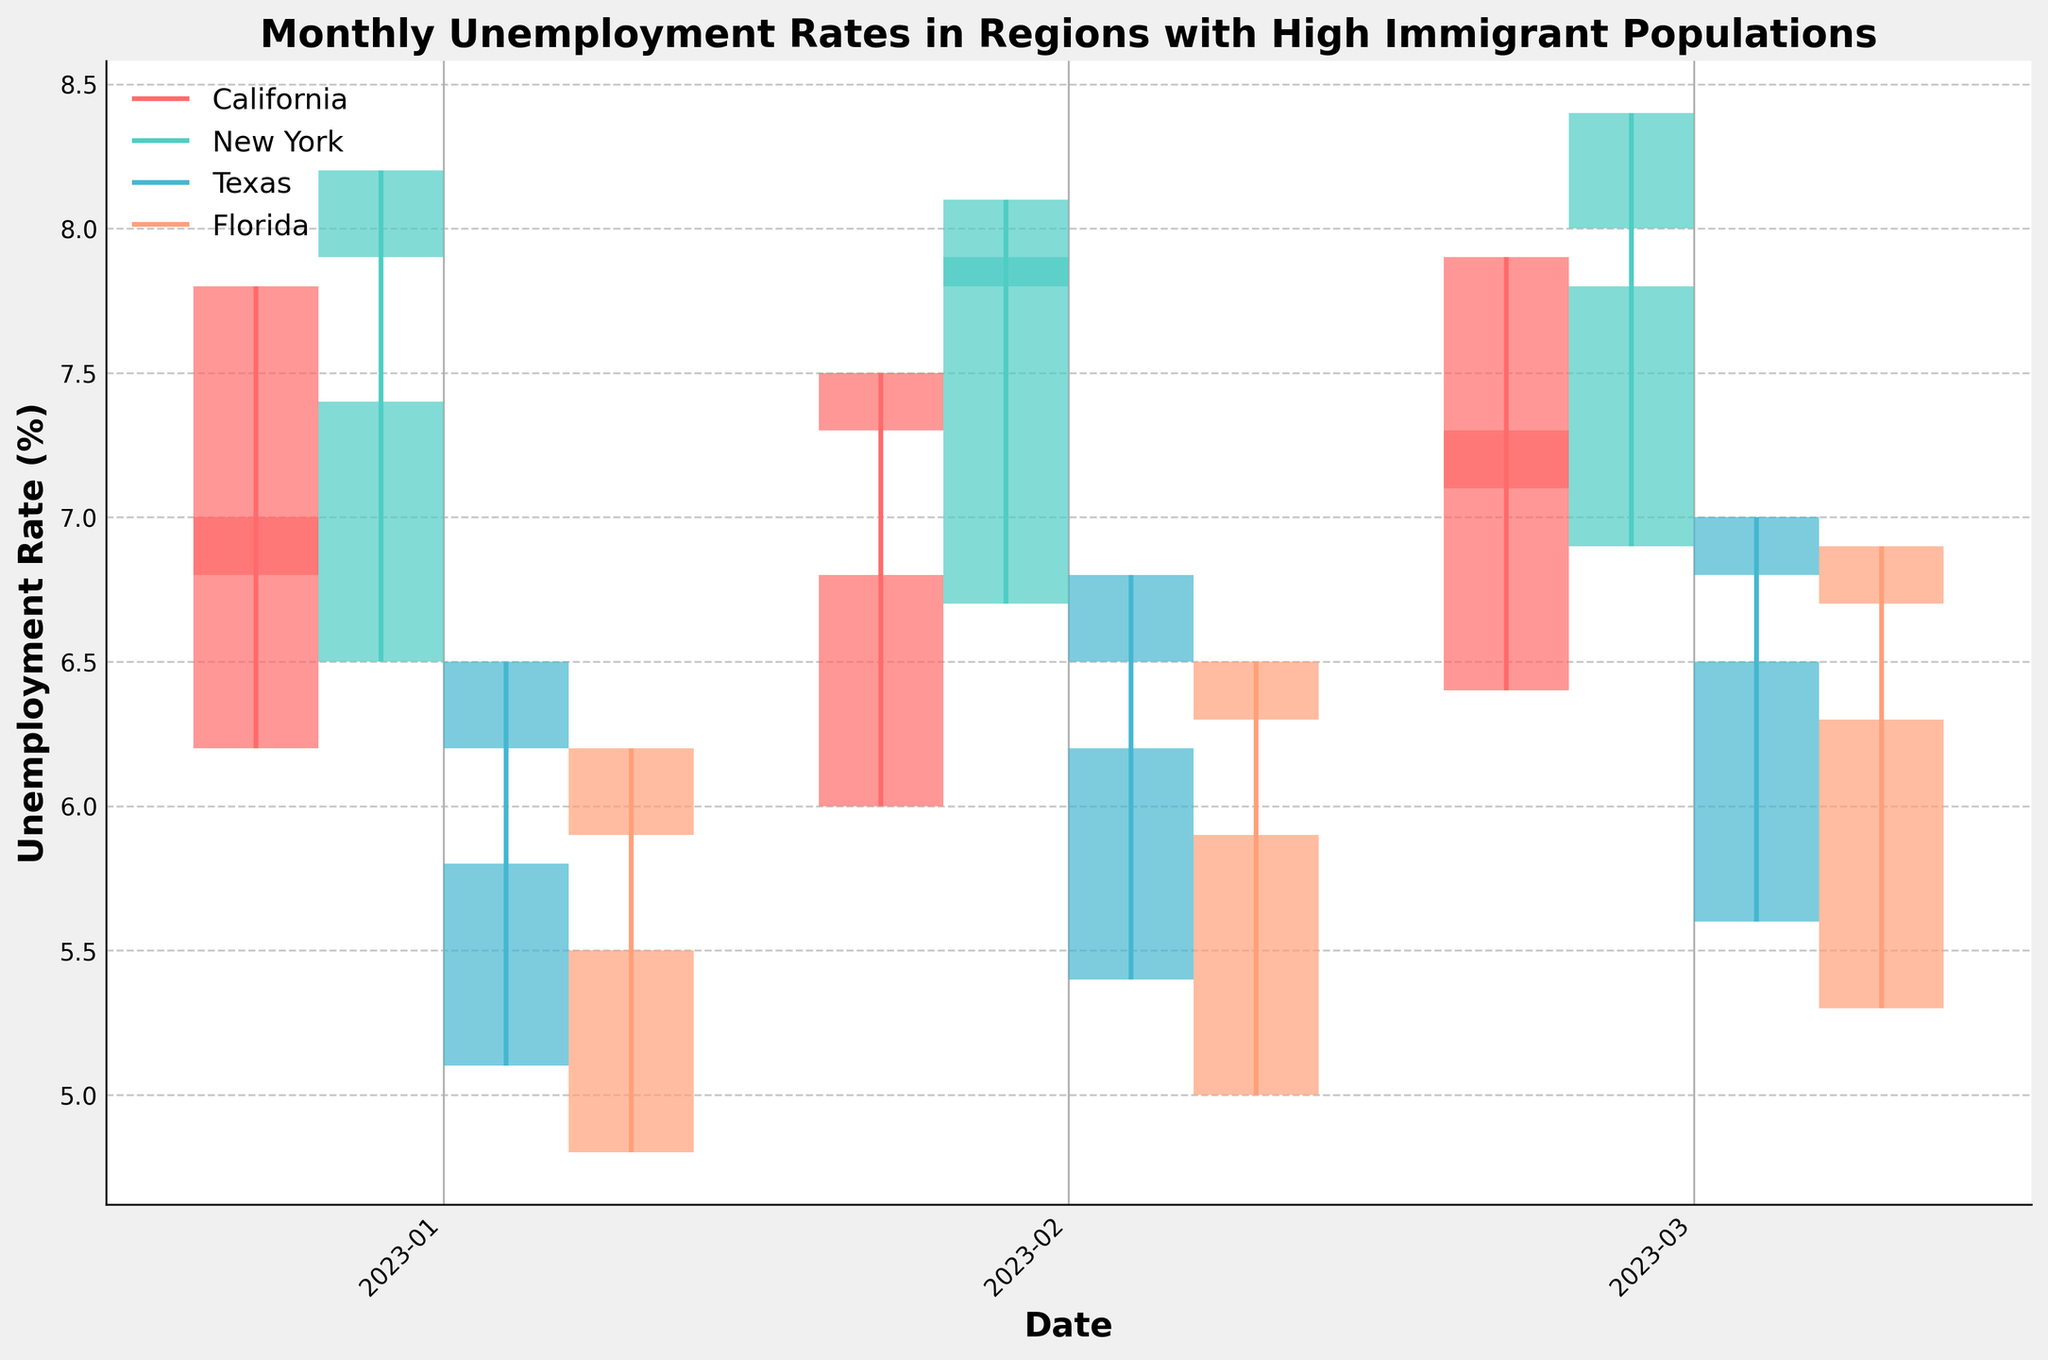Which region shows the highest unemployment rate in March 2023? To find the highest unemployment rate, look at the "High" values for March 2023. Among the regions, New York has the highest value of 8.4%.
Answer: New York Which region experienced the smallest range in unemployment rates in January 2023? The range can be determined by subtracting the "Low" value from the "High" value for January 2023. For California: 7.8 - 6.2 = 1.6, New York: 8.2 - 6.5 = 1.7, Texas: 6.5 - 5.1 = 1.4, Florida: 6.2 - 4.8 = 1.4. Both Texas and Florida have the smallest range of 1.4.
Answer: Texas and Florida What is the average "Close" value for New York in the first quarter of 2023? Identify the "Close" values for New York from January to March 2023 (7.9, 7.8, 8.0), then calculate the average: (7.9 + 7.8 + 8.0) / 3 = 7.9.
Answer: 7.9 Which region showed an increase in the "Close" value from January to February 2023? Compare the "Close" values between January and February. California: 6.8 to 7.3 (increase), New York: 7.9 to 7.8 (decrease), Texas: 6.2 to 6.5 (increase), Florida: 5.9 to 6.3 (increase). So, California, Texas, and Florida showed increases.
Answer: California, Texas, and Florida What's the highest "Low" value for Florida across the first quarter of 2023? Look at the "Low" values for Florida from January to March: 4.8, 5.0, and 5.3. The highest "Low" value is 5.3.
Answer: 5.3 In which month did Texas experience the highest "Close" value? Review Texas's "Close" values: January: 6.2, February: 6.5, March: 6.8. The highest "Close" value is 6.8 in March.
Answer: March How does California's "High" unemployment rate in February compare to Florida's "High" rate in the same month? Compare the "High" values in February: California: 7.5, Florida: 6.5. California's "High" unemployment rate is 1.0 higher than Florida's.
Answer: California is 1.0 higher Which month did New York see the greatest increase in "Low" values from the previous month? Calculate the increase in "Low" values for New York: January to February: 6.7 - 6.5 = 0.2, February to March: 6.9 - 6.7 = 0.2. Both months have the same increase.
Answer: Both January to February and February to March In March 2023, which region had the highest volatility in unemployment rates (difference between "High" and "Low")? Calculate the volatility for each region in March: California: 7.9 - 6.4 = 1.5, New York: 8.4 - 6.9 = 1.5, Texas: 7.0 - 5.6 = 1.4, Florida: 6.9 - 5.3 = 1.6. Florida had the highest volatility of 1.6.
Answer: Florida 